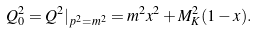<formula> <loc_0><loc_0><loc_500><loc_500>Q _ { 0 } ^ { 2 } = Q ^ { 2 } | _ { p ^ { 2 } = m ^ { 2 } } = m ^ { 2 } x ^ { 2 } + M _ { K } ^ { 2 } ( 1 - x ) .</formula> 